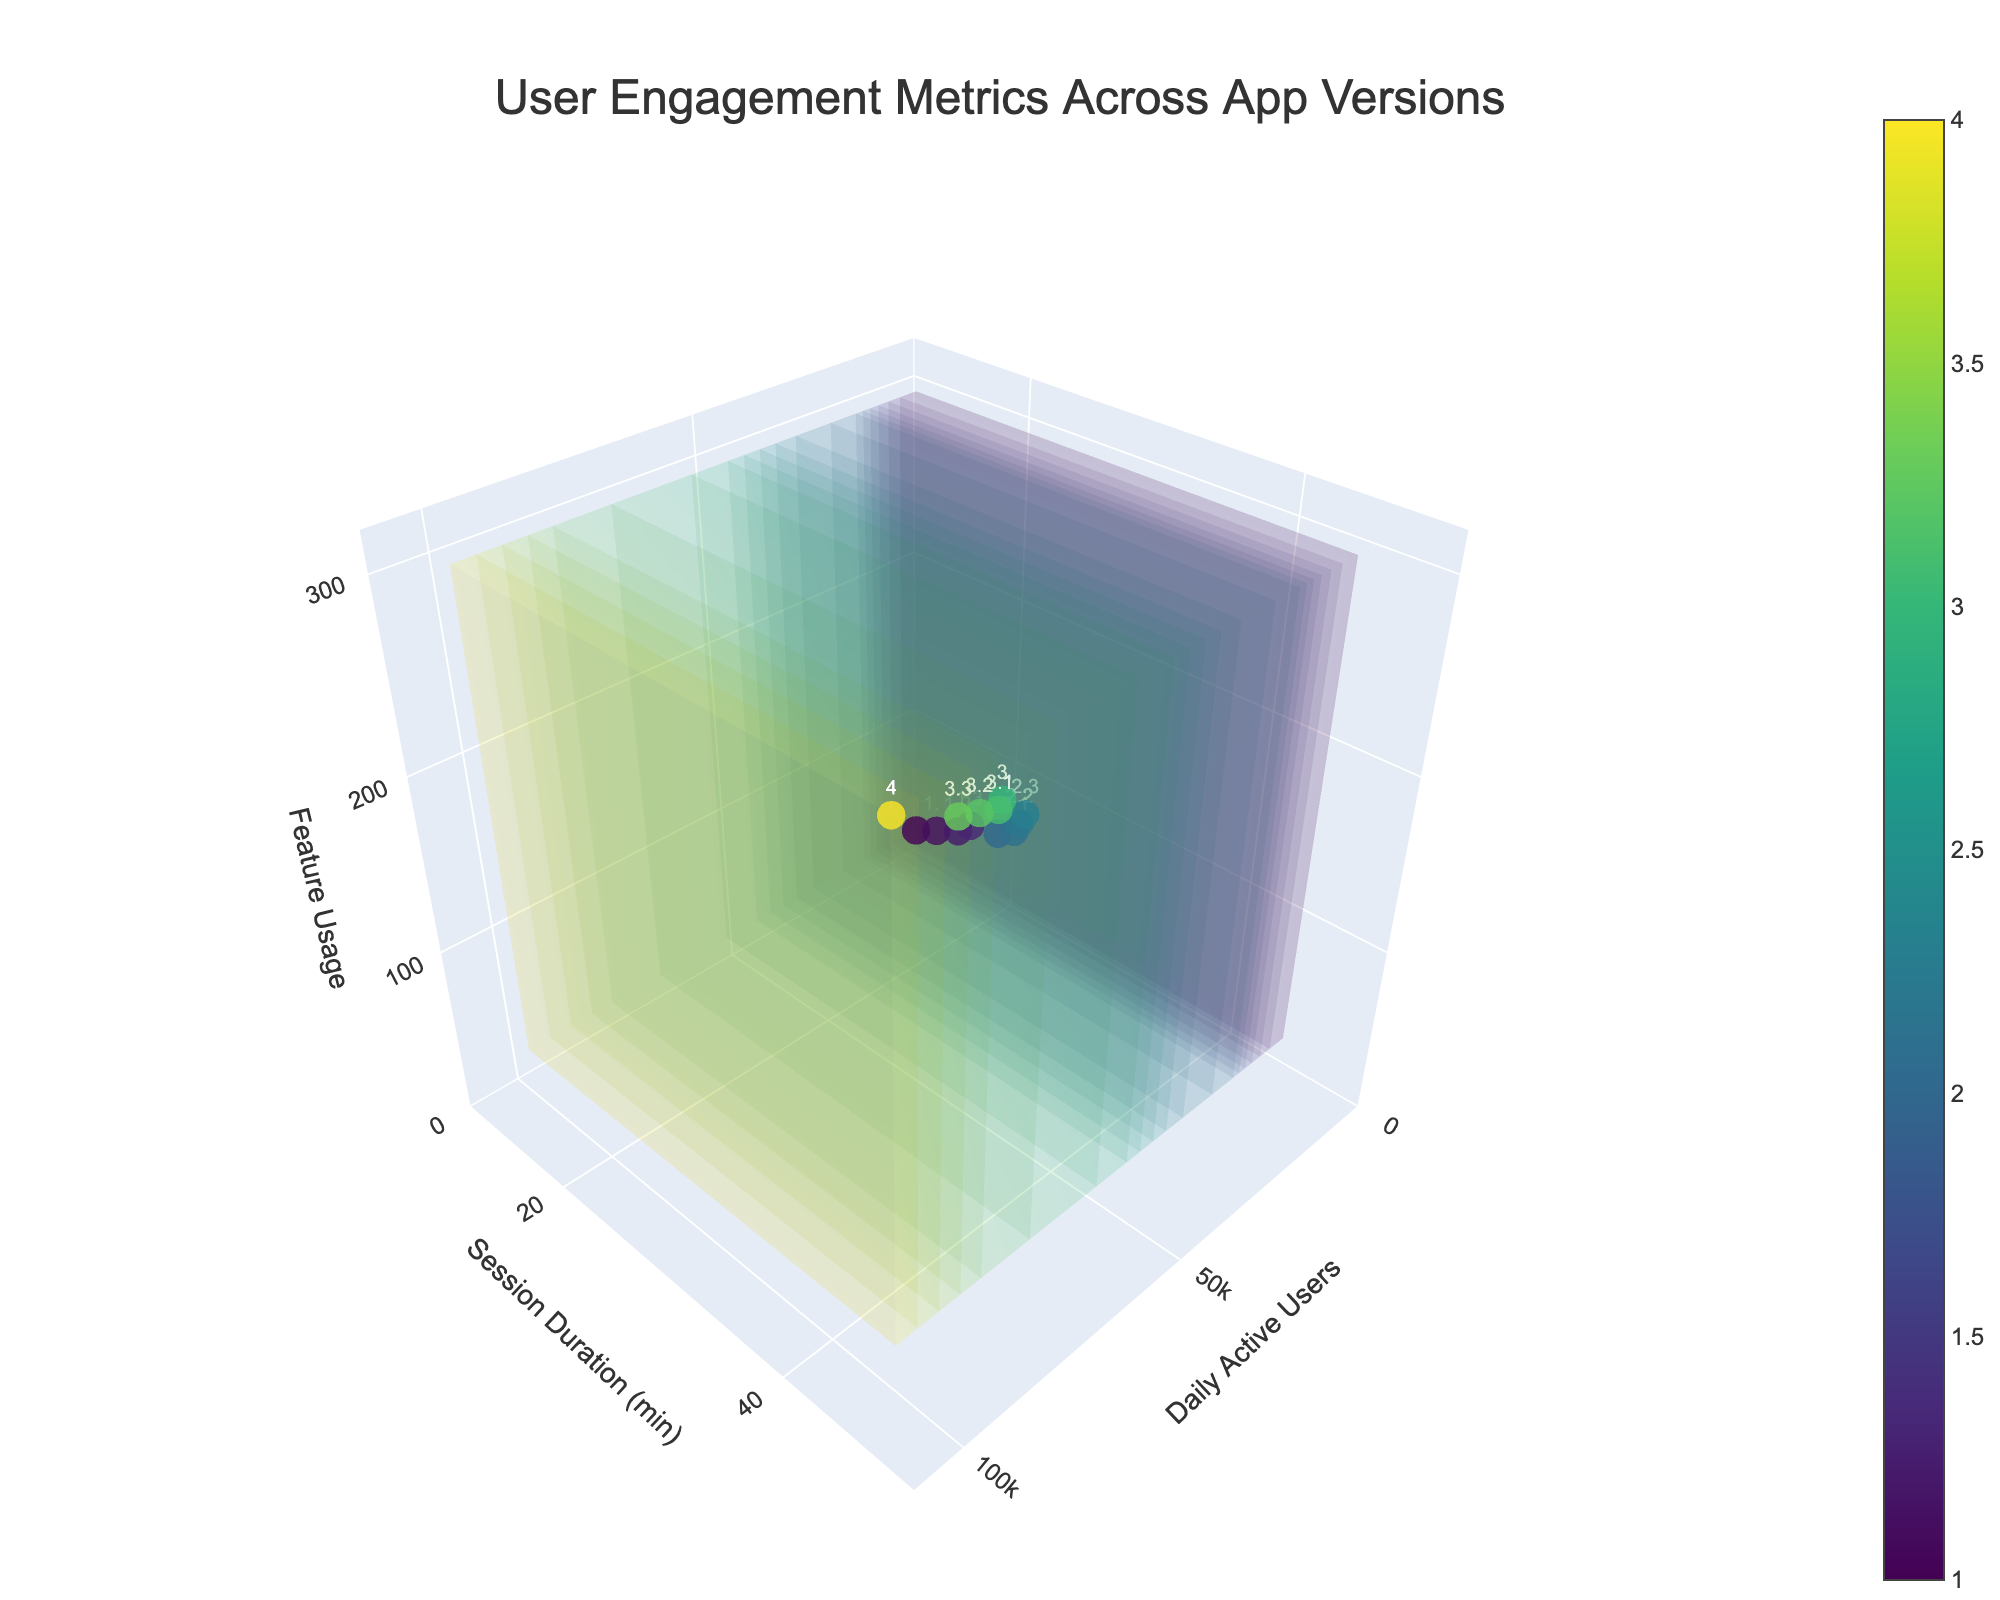How many versions of the app are displayed in the plot? The data mentions versions ranging from 1.0 to 4.0. These versions are plotted in the 3D volume plot, shown as marker points, labeled with their version numbers.
Answer: 13 What is the maximum value shown for session duration? The y-axis represents session duration in minutes. Observing the highest value along this axis, we can find the maximum session duration.
Answer: 45 How does feature usage change with the increase in daily active users from version 3.0 to version 4.0? By identifying the coordinates for versions 3.0 and 4.0, we compare the feature usage values along the z-axis (Feature Usage). Version 3.0 has about 200 and version 4.0 has 300, showing an increase.
Answer: Increases by 100 Between which two versions does the number of daily active users increase the most? By comparing the differences in daily active users along the x-axis for each version, it is clear that the jump from version 3.3 (80000) to version 4.0 (100000) is the largest.
Answer: 3.3 to 4.0 For version 2.2, is the feature usage closer to version 1.3 or version 2.0? Comparing the feature usage values (z-axis) for version 2.2 (140), version 1.3 (75), and version 2.0 (100), we observe that 140 is closer to 100 than 75.
Answer: 2.0 What trend can be observed in session duration as the app versions progress from 1.0 to 4.0? By looking at the y-axis coordinates for each version, we can see that the session duration generally increases with the app versions, from 12 minutes in 1.0 to 45 minutes in 4.0.
Answer: Increasing trend Is there any version where either daily active users or session duration decrease when compared to the previous version? Observing the dataset, we can see that both daily active users and session duration consistently increase from version to version.
Answer: No decrease What is the average session duration from the first version to the last? Summing up the session durations of all 13 versions (12+15+18+20+25+28+30+32+35+38+40+42+45) and dividing by the number of versions gives the average. (380/13 ≈ 29.23)
Answer: Approx. 29.23 minutes Which version shows the highest user engagement considering all three metrics (daily active users, session duration, and feature usage)? By highest user engagement, we assume maximizing all three metrics. Version 4.0 shows maximum values for daily active users (100000), session duration (45), and feature usage (300).
Answer: 4.0 How many increments in feature usage occur when moving from version 2.0 to version 2.3? Comparing feature usage (z-axis) for versions 2.0 (100) and 2.3 (160), the difference is 160 - 100 = 60.
Answer: 60 